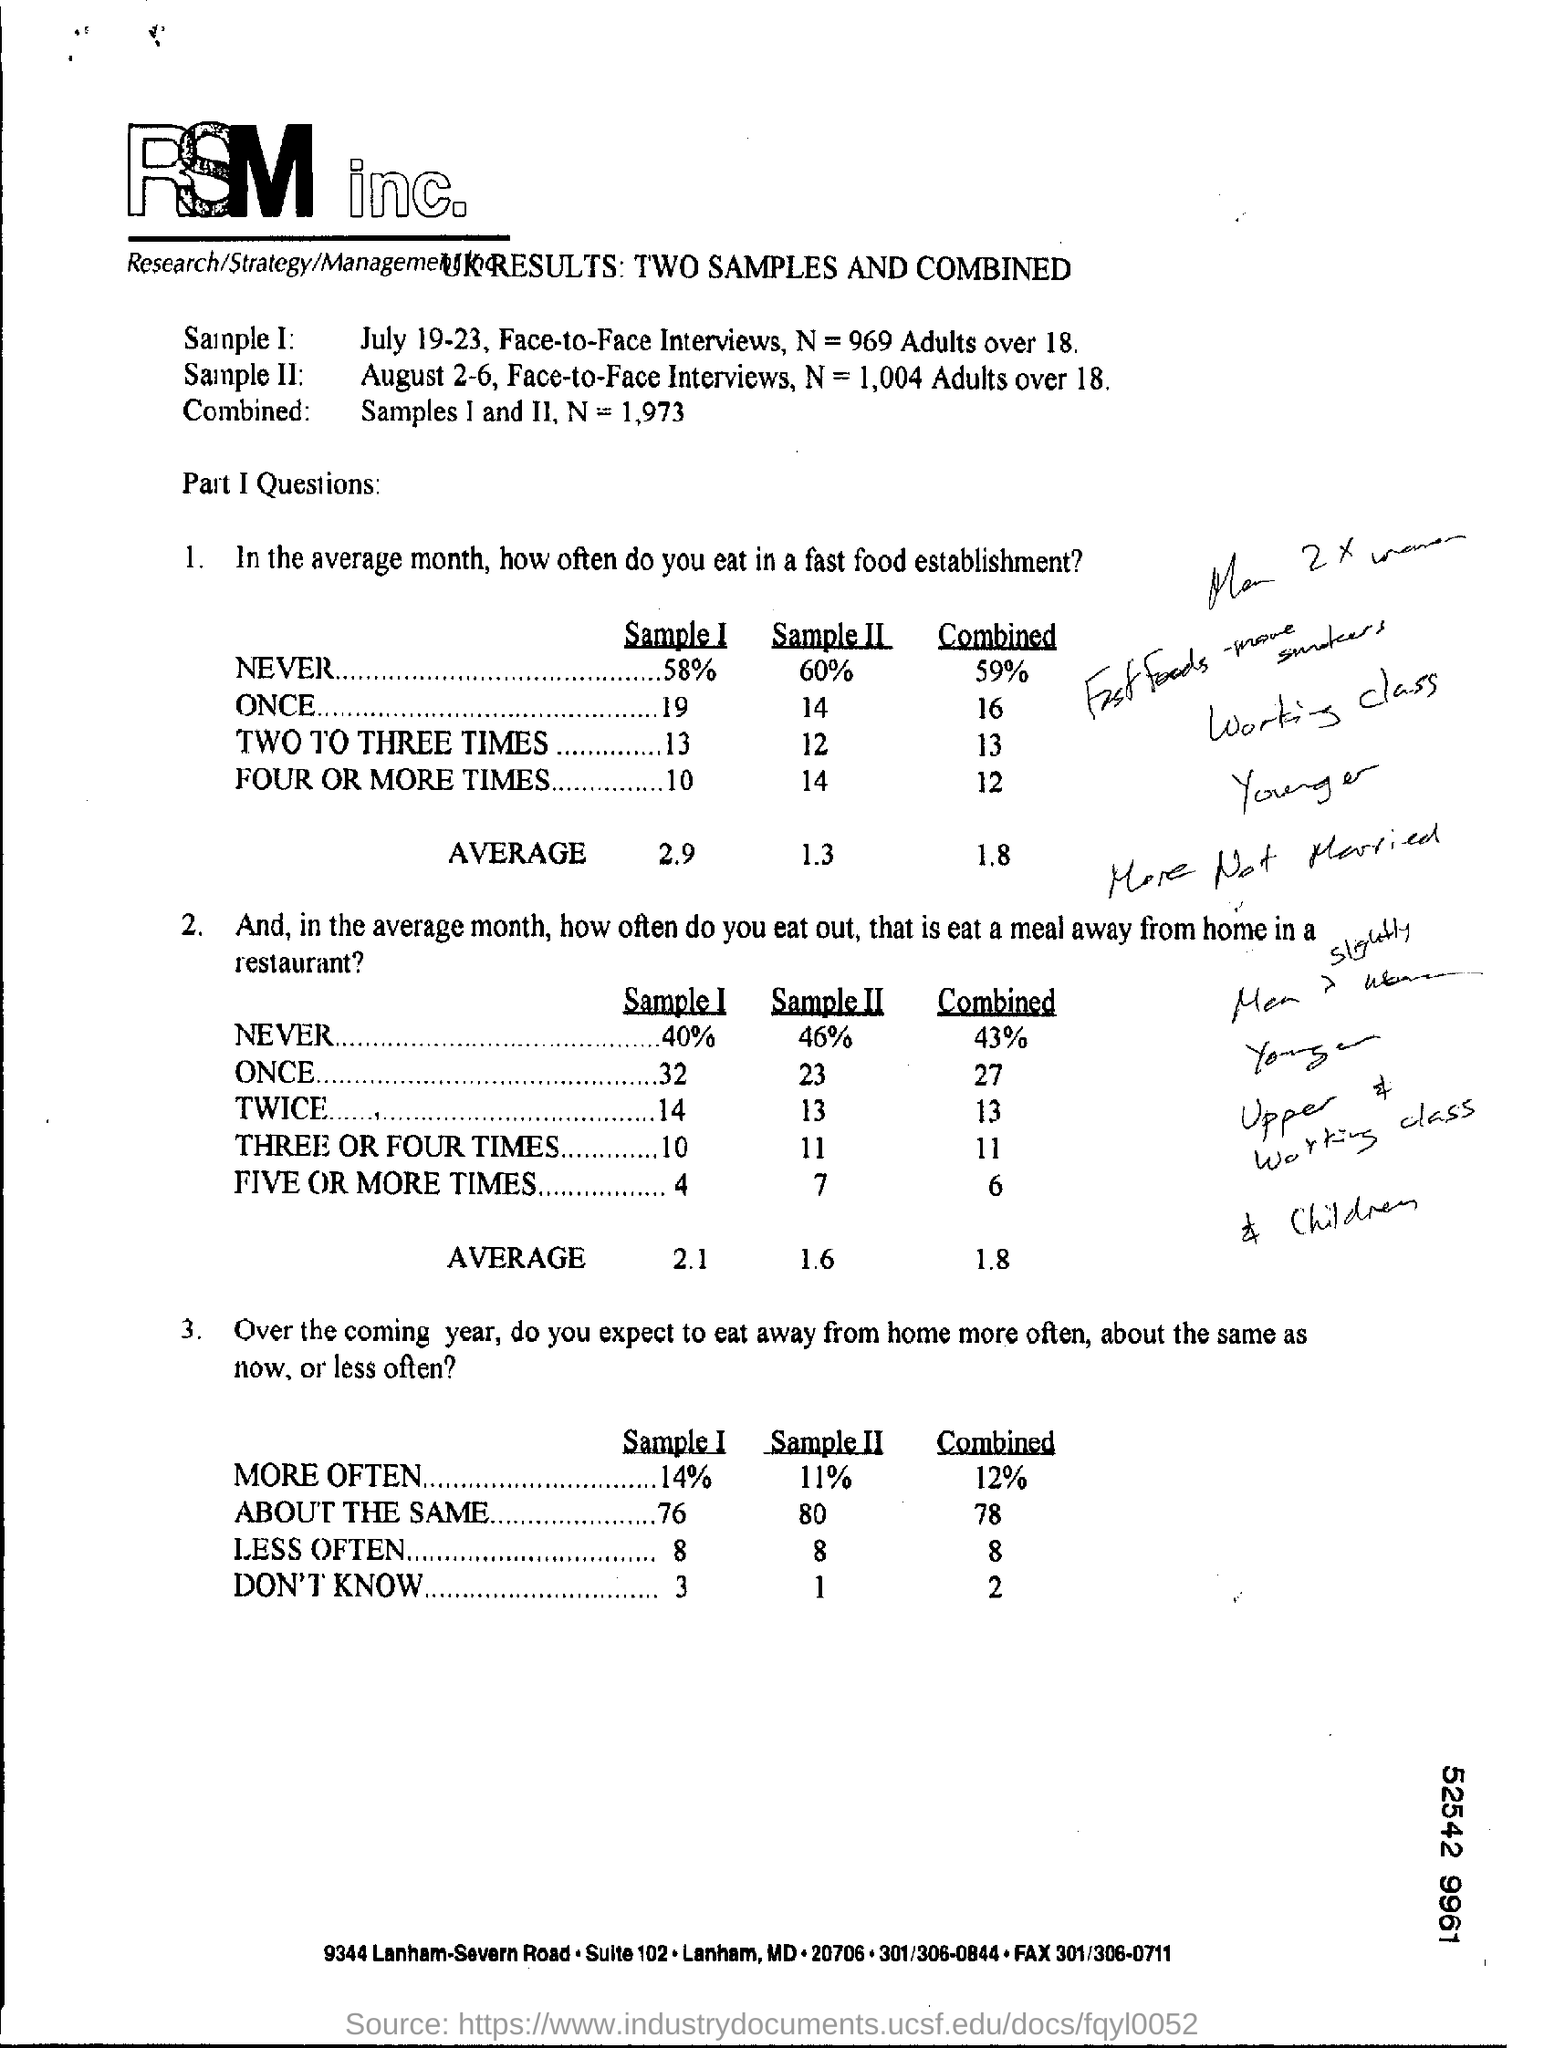Draw attention to some important aspects in this diagram. The average score for Sample I for Question 1 is 2.9. 